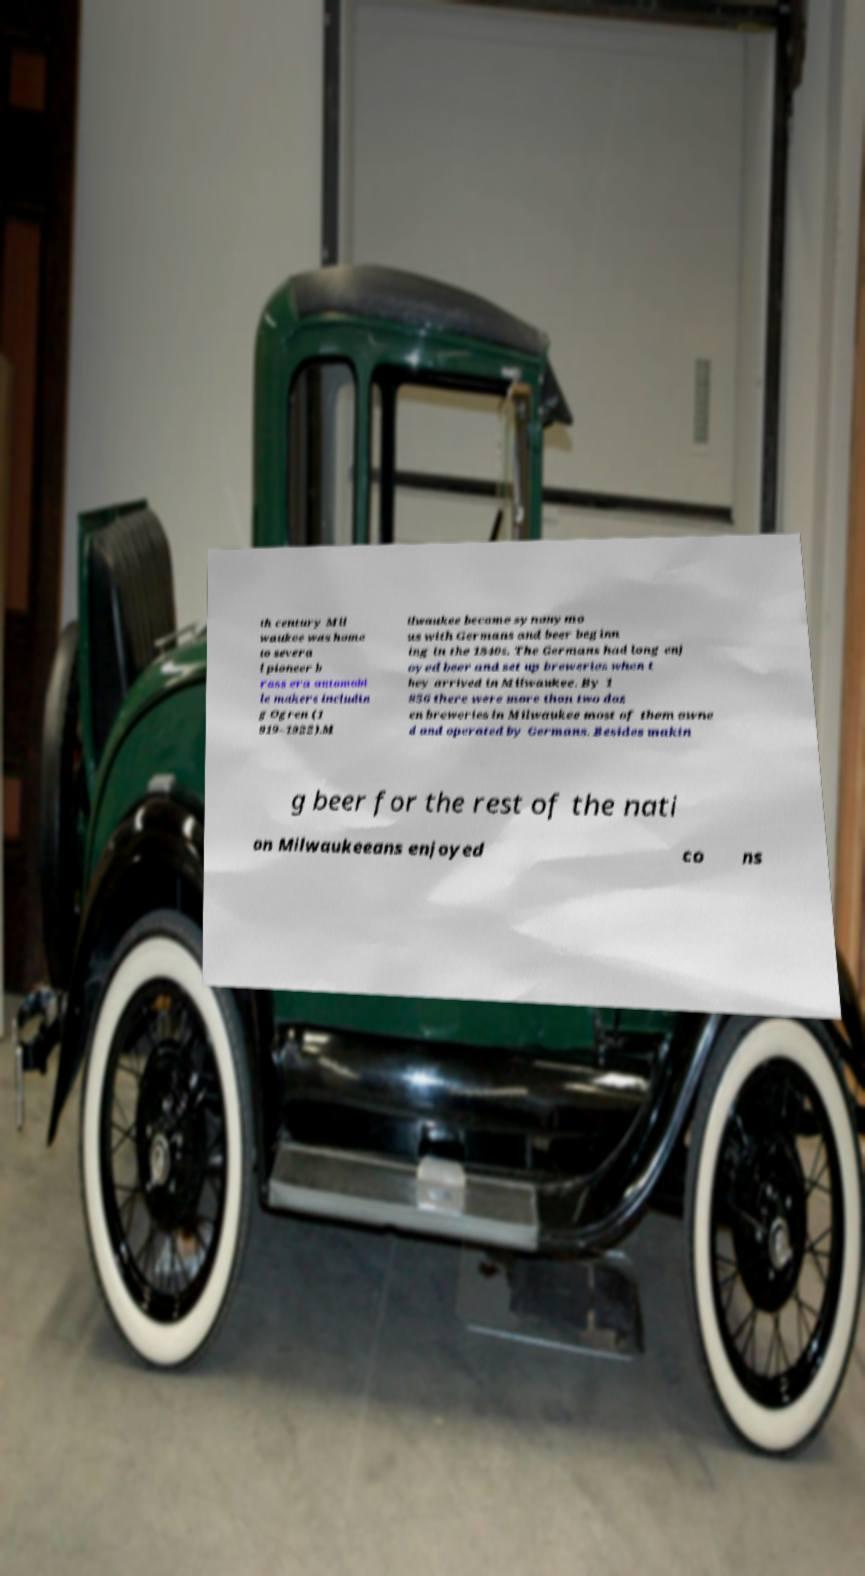There's text embedded in this image that I need extracted. Can you transcribe it verbatim? th century Mil waukee was home to severa l pioneer b rass era automobi le makers includin g Ogren (1 919–1922).M ilwaukee became synonymo us with Germans and beer beginn ing in the 1840s. The Germans had long enj oyed beer and set up breweries when t hey arrived in Milwaukee. By 1 856 there were more than two doz en breweries in Milwaukee most of them owne d and operated by Germans. Besides makin g beer for the rest of the nati on Milwaukeeans enjoyed co ns 